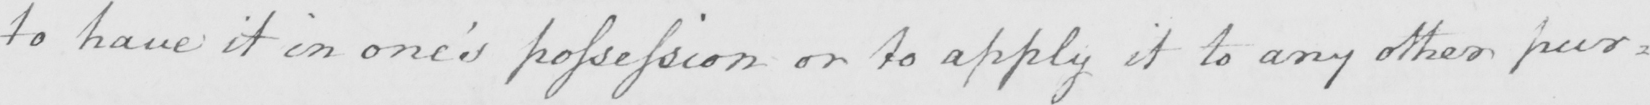What is written in this line of handwriting? to have it in one ' s possession or to apply it to any other pur= 